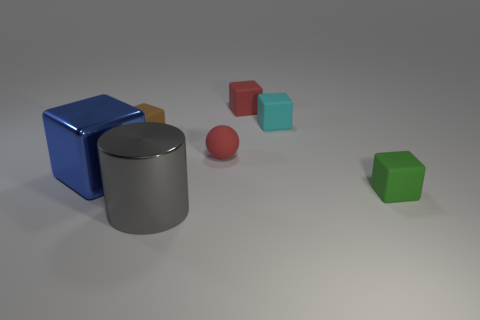Is the number of shiny blocks right of the small brown matte thing the same as the number of large blue objects? Upon examining the image, there is only one shiny block to the right of the small brown matte cylinder, while there is one large blue cube. So the answer is yes, there is the same number of shiny blocks to the right of the small brown matte cylinder as there are large blue objects. 